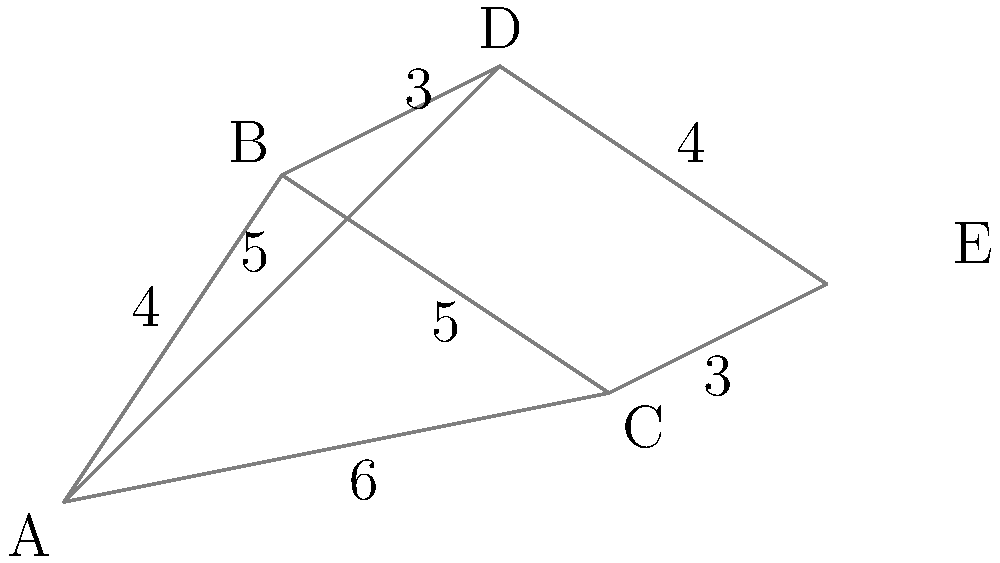Given the map of five cities (A, B, C, D, and E) with distances between them in kilometers, determine the shortest route to connect all cities with a new road network. What is the total length of this optimal road network? To find the shortest route connecting all cities, we need to use the concept of a Minimum Spanning Tree (MST). Here's how to solve this step-by-step:

1. List all edges and their weights (distances):
   A-B: 4, B-C: 5, C-E: 3, D-E: 4, B-D: 3, A-C: 6, A-D: 5

2. Sort edges by weight in ascending order:
   B-D: 3, C-E: 3, A-B: 4, D-E: 4, B-C: 5, A-D: 5, A-C: 6

3. Apply Kruskal's algorithm to find the MST:
   a) Add B-D (3km)
   b) Add C-E (3km)
   c) Add A-B (4km)
   d) Add D-E (4km)

4. After these four edges, we have connected all five cities without creating any cycles.

5. Calculate the total length of the optimal road network:
   $$ \text{Total length} = 3 + 3 + 4 + 4 = 14\text{ km} $$

Therefore, the shortest route to connect all cities is 14 km long.
Answer: 14 km 